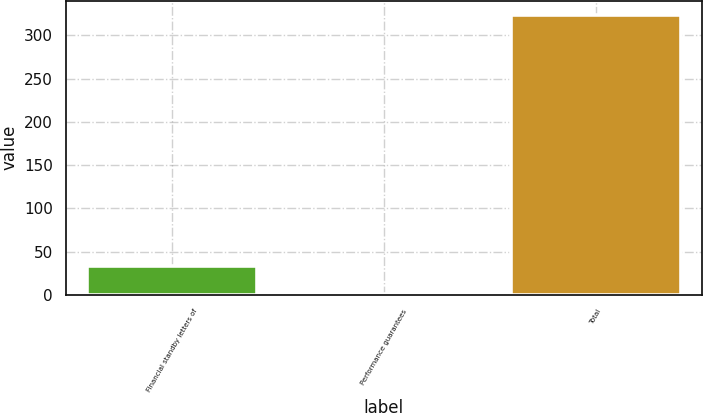Convert chart to OTSL. <chart><loc_0><loc_0><loc_500><loc_500><bar_chart><fcel>Financial standby letters of<fcel>Performance guarantees<fcel>Total<nl><fcel>32.95<fcel>0.6<fcel>324.1<nl></chart> 